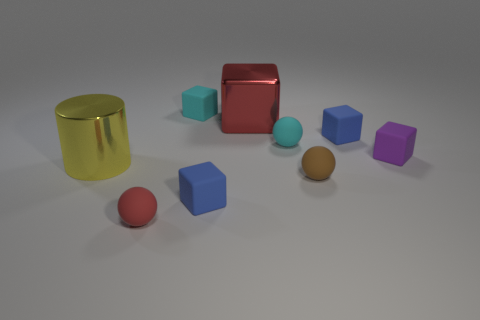What shape is the small object that is behind the large yellow object and left of the cyan sphere?
Ensure brevity in your answer.  Cube. How many things are tiny blue rubber cubes that are behind the big yellow cylinder or small matte things that are on the right side of the red block?
Offer a terse response. 4. How many other things are there of the same size as the brown matte object?
Provide a short and direct response. 6. There is a block that is behind the big red thing; does it have the same color as the big shiny block?
Provide a succinct answer. No. There is a thing that is both in front of the tiny purple thing and behind the tiny brown rubber thing; how big is it?
Make the answer very short. Large. What number of tiny objects are either yellow things or red cubes?
Provide a short and direct response. 0. There is a blue matte object that is on the right side of the cyan sphere; what is its shape?
Ensure brevity in your answer.  Cube. What number of small matte things are there?
Your answer should be compact. 7. Do the big yellow thing and the small cyan sphere have the same material?
Offer a very short reply. No. Are there more tiny blue rubber cubes to the left of the yellow shiny cylinder than large yellow cylinders?
Ensure brevity in your answer.  No. 